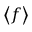<formula> <loc_0><loc_0><loc_500><loc_500>\left \langle f \right \rangle</formula> 